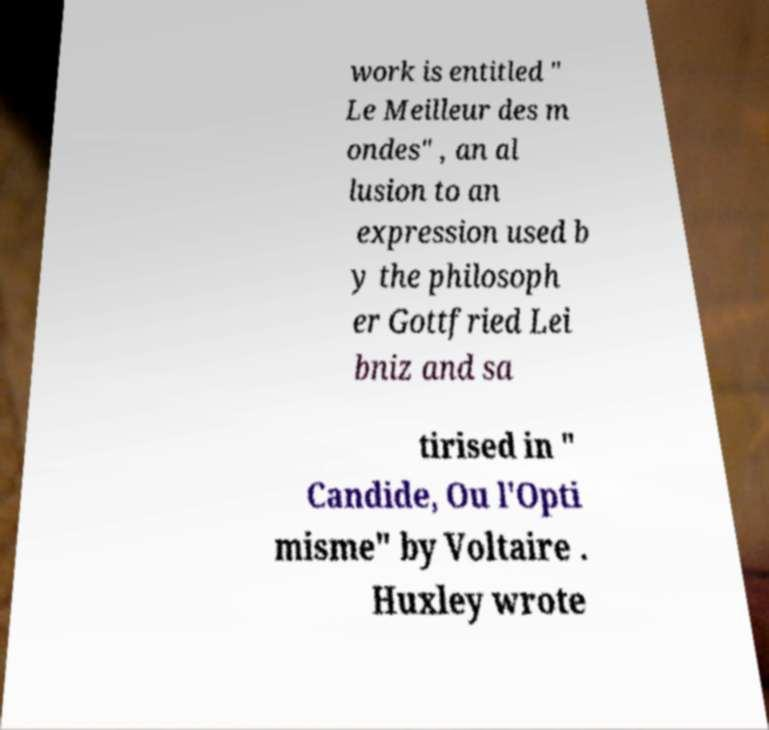What messages or text are displayed in this image? I need them in a readable, typed format. work is entitled " Le Meilleur des m ondes" , an al lusion to an expression used b y the philosoph er Gottfried Lei bniz and sa tirised in " Candide, Ou l'Opti misme" by Voltaire . Huxley wrote 